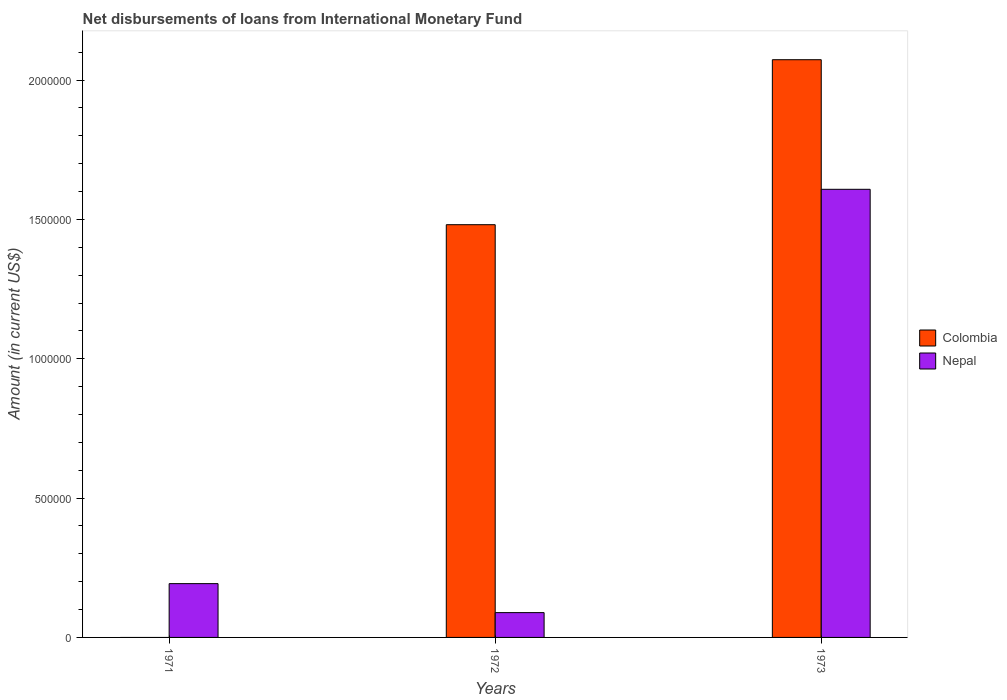Are the number of bars on each tick of the X-axis equal?
Provide a short and direct response. No. How many bars are there on the 1st tick from the right?
Keep it short and to the point. 2. In how many cases, is the number of bars for a given year not equal to the number of legend labels?
Make the answer very short. 1. What is the amount of loans disbursed in Colombia in 1973?
Your response must be concise. 2.07e+06. Across all years, what is the maximum amount of loans disbursed in Colombia?
Offer a very short reply. 2.07e+06. Across all years, what is the minimum amount of loans disbursed in Nepal?
Provide a short and direct response. 8.90e+04. In which year was the amount of loans disbursed in Nepal maximum?
Provide a short and direct response. 1973. What is the total amount of loans disbursed in Colombia in the graph?
Offer a terse response. 3.55e+06. What is the difference between the amount of loans disbursed in Nepal in 1972 and that in 1973?
Make the answer very short. -1.52e+06. What is the difference between the amount of loans disbursed in Nepal in 1973 and the amount of loans disbursed in Colombia in 1971?
Make the answer very short. 1.61e+06. What is the average amount of loans disbursed in Nepal per year?
Make the answer very short. 6.30e+05. In the year 1972, what is the difference between the amount of loans disbursed in Colombia and amount of loans disbursed in Nepal?
Your response must be concise. 1.39e+06. In how many years, is the amount of loans disbursed in Colombia greater than 1900000 US$?
Keep it short and to the point. 1. What is the ratio of the amount of loans disbursed in Nepal in 1971 to that in 1973?
Ensure brevity in your answer.  0.12. What is the difference between the highest and the second highest amount of loans disbursed in Nepal?
Make the answer very short. 1.42e+06. What is the difference between the highest and the lowest amount of loans disbursed in Nepal?
Give a very brief answer. 1.52e+06. In how many years, is the amount of loans disbursed in Nepal greater than the average amount of loans disbursed in Nepal taken over all years?
Offer a very short reply. 1. Are the values on the major ticks of Y-axis written in scientific E-notation?
Offer a very short reply. No. Does the graph contain grids?
Your answer should be very brief. No. How many legend labels are there?
Provide a succinct answer. 2. How are the legend labels stacked?
Your answer should be very brief. Vertical. What is the title of the graph?
Offer a very short reply. Net disbursements of loans from International Monetary Fund. What is the label or title of the X-axis?
Offer a terse response. Years. What is the label or title of the Y-axis?
Your answer should be compact. Amount (in current US$). What is the Amount (in current US$) of Colombia in 1971?
Provide a short and direct response. 0. What is the Amount (in current US$) of Nepal in 1971?
Ensure brevity in your answer.  1.93e+05. What is the Amount (in current US$) in Colombia in 1972?
Offer a terse response. 1.48e+06. What is the Amount (in current US$) in Nepal in 1972?
Offer a terse response. 8.90e+04. What is the Amount (in current US$) of Colombia in 1973?
Provide a short and direct response. 2.07e+06. What is the Amount (in current US$) in Nepal in 1973?
Provide a succinct answer. 1.61e+06. Across all years, what is the maximum Amount (in current US$) in Colombia?
Ensure brevity in your answer.  2.07e+06. Across all years, what is the maximum Amount (in current US$) in Nepal?
Your answer should be very brief. 1.61e+06. Across all years, what is the minimum Amount (in current US$) in Nepal?
Your answer should be compact. 8.90e+04. What is the total Amount (in current US$) of Colombia in the graph?
Offer a very short reply. 3.55e+06. What is the total Amount (in current US$) of Nepal in the graph?
Make the answer very short. 1.89e+06. What is the difference between the Amount (in current US$) of Nepal in 1971 and that in 1972?
Ensure brevity in your answer.  1.04e+05. What is the difference between the Amount (in current US$) in Nepal in 1971 and that in 1973?
Your response must be concise. -1.42e+06. What is the difference between the Amount (in current US$) in Colombia in 1972 and that in 1973?
Provide a succinct answer. -5.92e+05. What is the difference between the Amount (in current US$) in Nepal in 1972 and that in 1973?
Keep it short and to the point. -1.52e+06. What is the difference between the Amount (in current US$) in Colombia in 1972 and the Amount (in current US$) in Nepal in 1973?
Your answer should be very brief. -1.27e+05. What is the average Amount (in current US$) of Colombia per year?
Your response must be concise. 1.18e+06. What is the average Amount (in current US$) of Nepal per year?
Keep it short and to the point. 6.30e+05. In the year 1972, what is the difference between the Amount (in current US$) in Colombia and Amount (in current US$) in Nepal?
Provide a succinct answer. 1.39e+06. In the year 1973, what is the difference between the Amount (in current US$) in Colombia and Amount (in current US$) in Nepal?
Your response must be concise. 4.65e+05. What is the ratio of the Amount (in current US$) of Nepal in 1971 to that in 1972?
Offer a very short reply. 2.17. What is the ratio of the Amount (in current US$) of Nepal in 1971 to that in 1973?
Your response must be concise. 0.12. What is the ratio of the Amount (in current US$) of Colombia in 1972 to that in 1973?
Provide a succinct answer. 0.71. What is the ratio of the Amount (in current US$) of Nepal in 1972 to that in 1973?
Your response must be concise. 0.06. What is the difference between the highest and the second highest Amount (in current US$) of Nepal?
Your response must be concise. 1.42e+06. What is the difference between the highest and the lowest Amount (in current US$) in Colombia?
Your answer should be very brief. 2.07e+06. What is the difference between the highest and the lowest Amount (in current US$) of Nepal?
Your answer should be compact. 1.52e+06. 